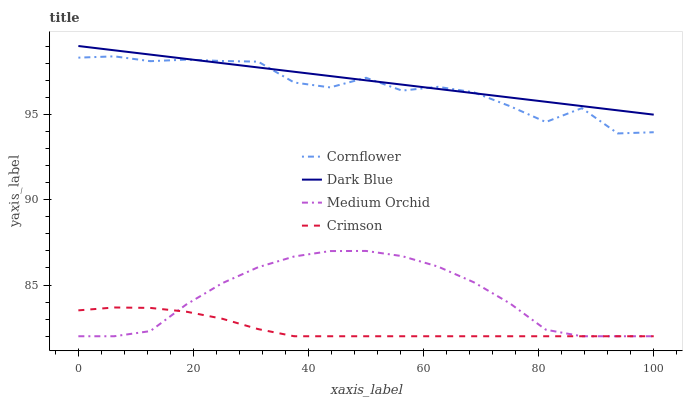Does Crimson have the minimum area under the curve?
Answer yes or no. Yes. Does Dark Blue have the maximum area under the curve?
Answer yes or no. Yes. Does Cornflower have the minimum area under the curve?
Answer yes or no. No. Does Cornflower have the maximum area under the curve?
Answer yes or no. No. Is Dark Blue the smoothest?
Answer yes or no. Yes. Is Cornflower the roughest?
Answer yes or no. Yes. Is Medium Orchid the smoothest?
Answer yes or no. No. Is Medium Orchid the roughest?
Answer yes or no. No. Does Crimson have the lowest value?
Answer yes or no. Yes. Does Cornflower have the lowest value?
Answer yes or no. No. Does Dark Blue have the highest value?
Answer yes or no. Yes. Does Cornflower have the highest value?
Answer yes or no. No. Is Crimson less than Dark Blue?
Answer yes or no. Yes. Is Cornflower greater than Crimson?
Answer yes or no. Yes. Does Dark Blue intersect Cornflower?
Answer yes or no. Yes. Is Dark Blue less than Cornflower?
Answer yes or no. No. Is Dark Blue greater than Cornflower?
Answer yes or no. No. Does Crimson intersect Dark Blue?
Answer yes or no. No. 